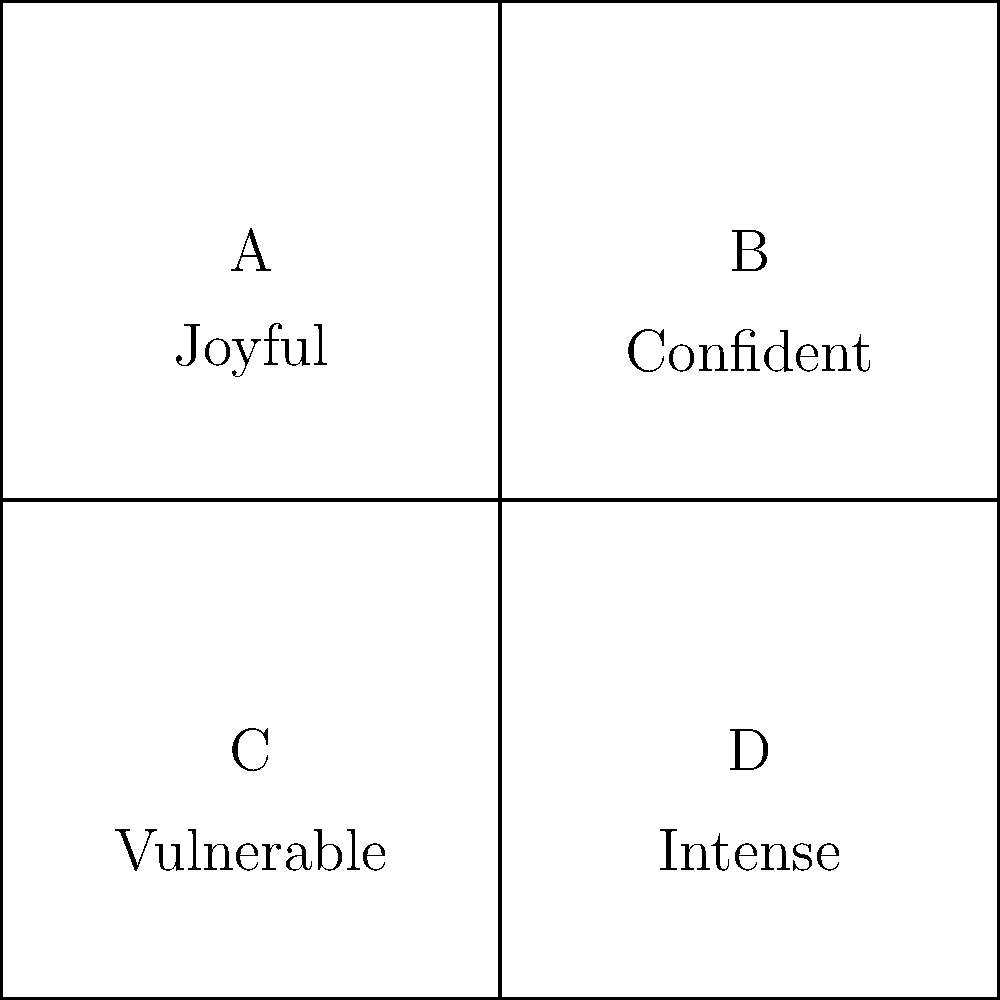As a theater industry influencer, you're reviewing headshots of aspiring actors. Based on the emotional expressions depicted in the grid above, which combination would you recommend for an actor auditioning for a complex role that requires both strength and sensitivity? To answer this question, we need to analyze the emotional expressions presented in each headshot and determine which combination best represents both strength and sensitivity. Let's break it down step-by-step:

1. Examine each headshot:
   A: Joyful - This expression conveys positivity but doesn't directly relate to strength or sensitivity.
   B: Confident - This expression relates to strength.
   C: Vulnerable - This expression relates to sensitivity.
   D: Intense - This expression could relate to strength, depending on the context.

2. Identify the requirements for the role:
   - Strength: Often associated with confidence and intensity.
   - Sensitivity: Often associated with vulnerability and emotional openness.

3. Determine the best combination:
   - We need one expression that conveys strength and one that conveys sensitivity.
   - The most suitable combination would be B (Confident) and C (Vulnerable).

4. Justify the choice:
   - Confidence (B) demonstrates the actor's ability to portray strength.
   - Vulnerability (C) showcases the actor's capacity for sensitivity and emotional depth.
   - This combination suggests the actor can transition between these contrasting emotional states, which is crucial for a complex role.

5. Consider alternatives:
   - While D (Intense) could potentially represent strength, B (Confident) is a clearer indicator of this quality in the context of acting.
   - A (Joyful) doesn't directly contribute to the specific requirements of strength and sensitivity for this role.

Therefore, the best recommendation for an actor auditioning for a complex role requiring both strength and sensitivity would be the combination of headshots B and C.
Answer: B and C 